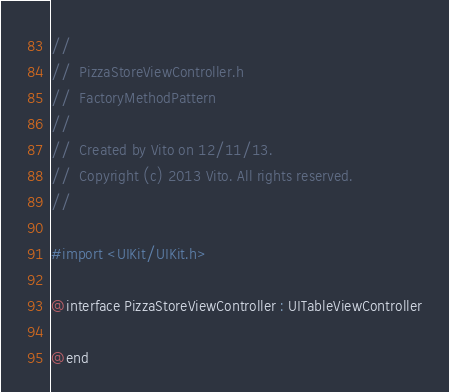<code> <loc_0><loc_0><loc_500><loc_500><_C_>//
//  PizzaStoreViewController.h
//  FactoryMethodPattern
//
//  Created by Vito on 12/11/13.
//  Copyright (c) 2013 Vito. All rights reserved.
//

#import <UIKit/UIKit.h>

@interface PizzaStoreViewController : UITableViewController

@end
</code> 